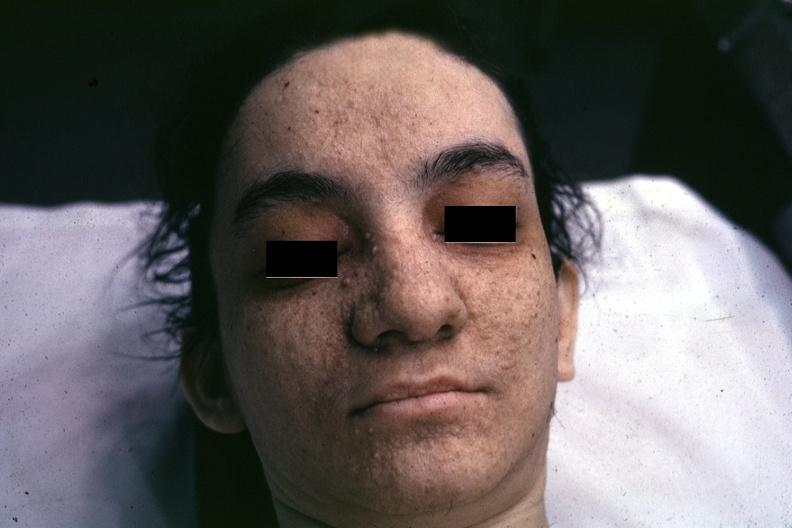s opened uterus and cervix with large cervical myoma protruding into vagina slide present?
Answer the question using a single word or phrase. No 